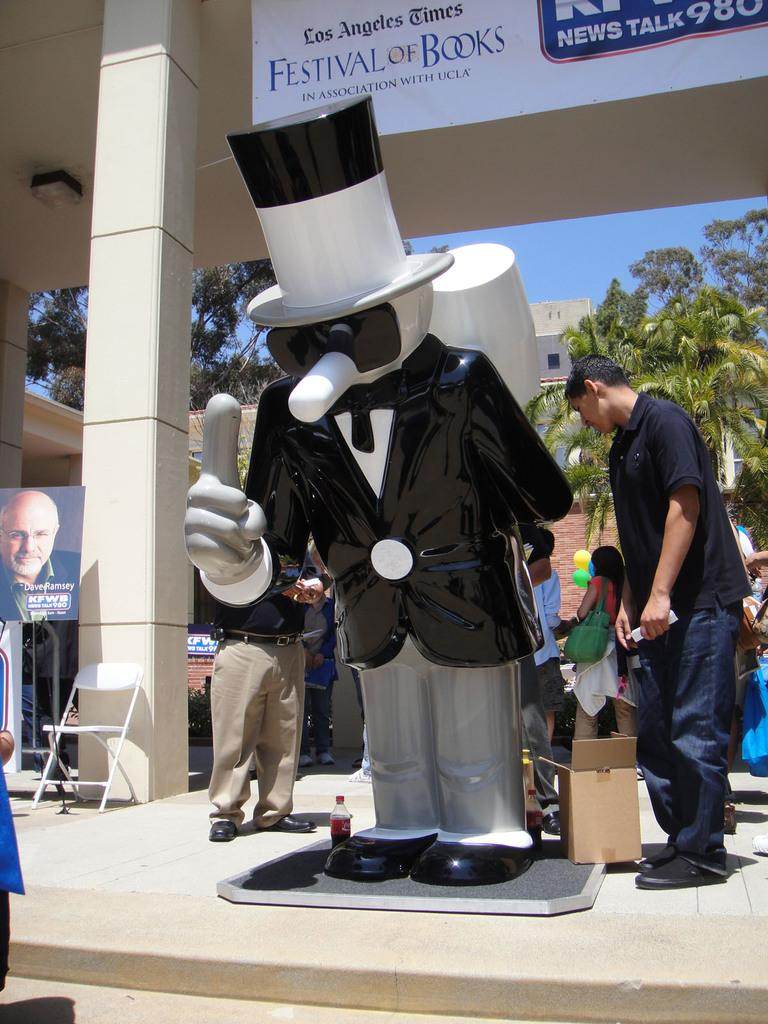What is located in the middle of the image? There are statues of idols in the middle of the image. What can be seen behind the statues? There are many people standing behind the statues. What is visible in the background of the image? There are buildings and trees in the background of the image. What is visible above the image? The sky is visible above the image. Can you tell me when the plane is scheduled to start in the image? There is no plane or mention of a start time in the image; it features statues of idols, people, buildings, trees, and the sky. 